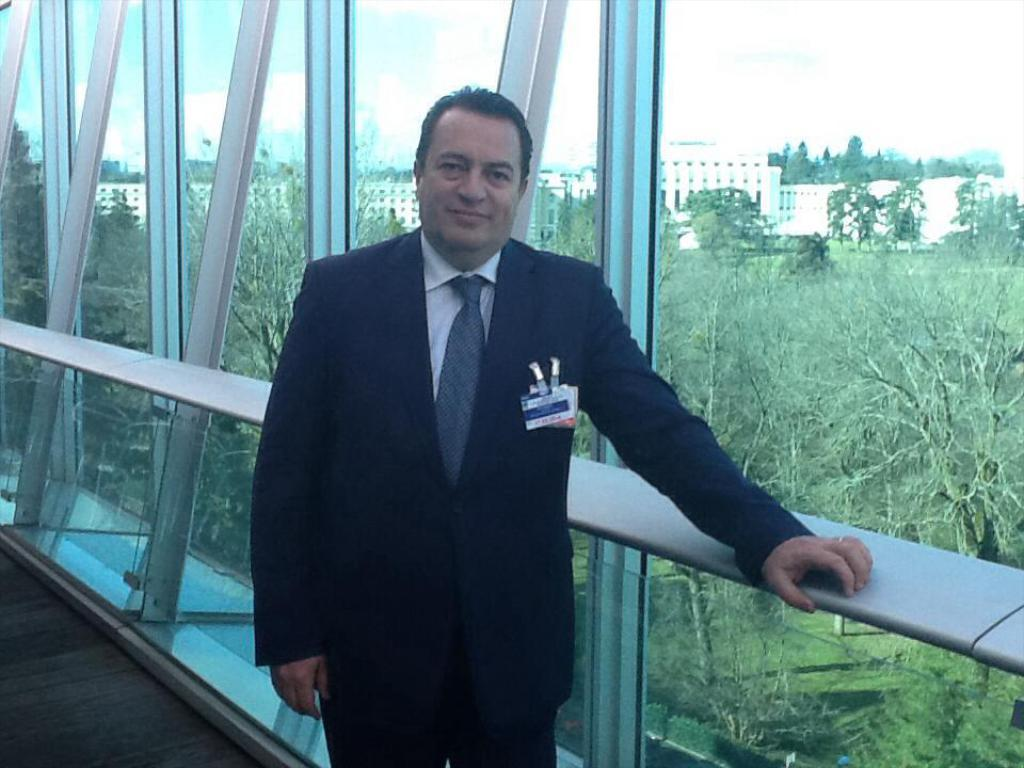Who is the main subject in the foreground of the picture? There is a man in the foreground of the picture. What is the man wearing in the image? The man is wearing a black suit. What can be seen beside the man in the image? There are windows beside the man. What is visible outside the windows in the image? Trees and buildings are visible outside the windows. What is the condition of the sky in the image? The sky is cloudy in the image. How does the man sort the destruction in the image? There is no destruction present in the image, and the man is not sorting anything. Is the image quiet or noisy? The image itself is silent, as it is a still photograph, but we cannot determine the noise level in the depicted scene. 